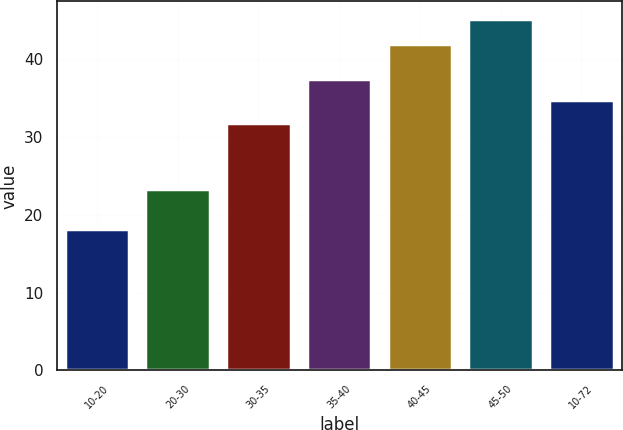Convert chart. <chart><loc_0><loc_0><loc_500><loc_500><bar_chart><fcel>10-20<fcel>20-30<fcel>30-35<fcel>35-40<fcel>40-45<fcel>45-50<fcel>10-72<nl><fcel>18.16<fcel>23.34<fcel>31.73<fcel>37.36<fcel>41.97<fcel>45.14<fcel>34.66<nl></chart> 